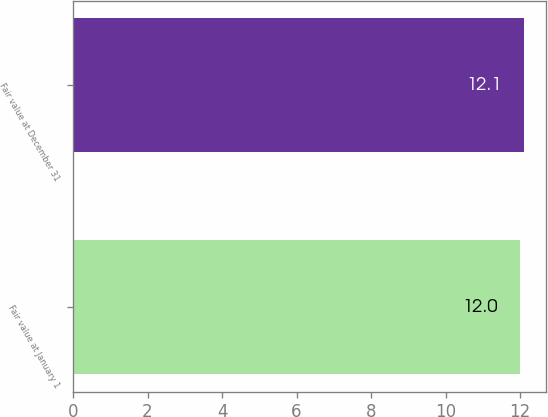<chart> <loc_0><loc_0><loc_500><loc_500><bar_chart><fcel>Fair value at January 1<fcel>Fair value at December 31<nl><fcel>12<fcel>12.1<nl></chart> 